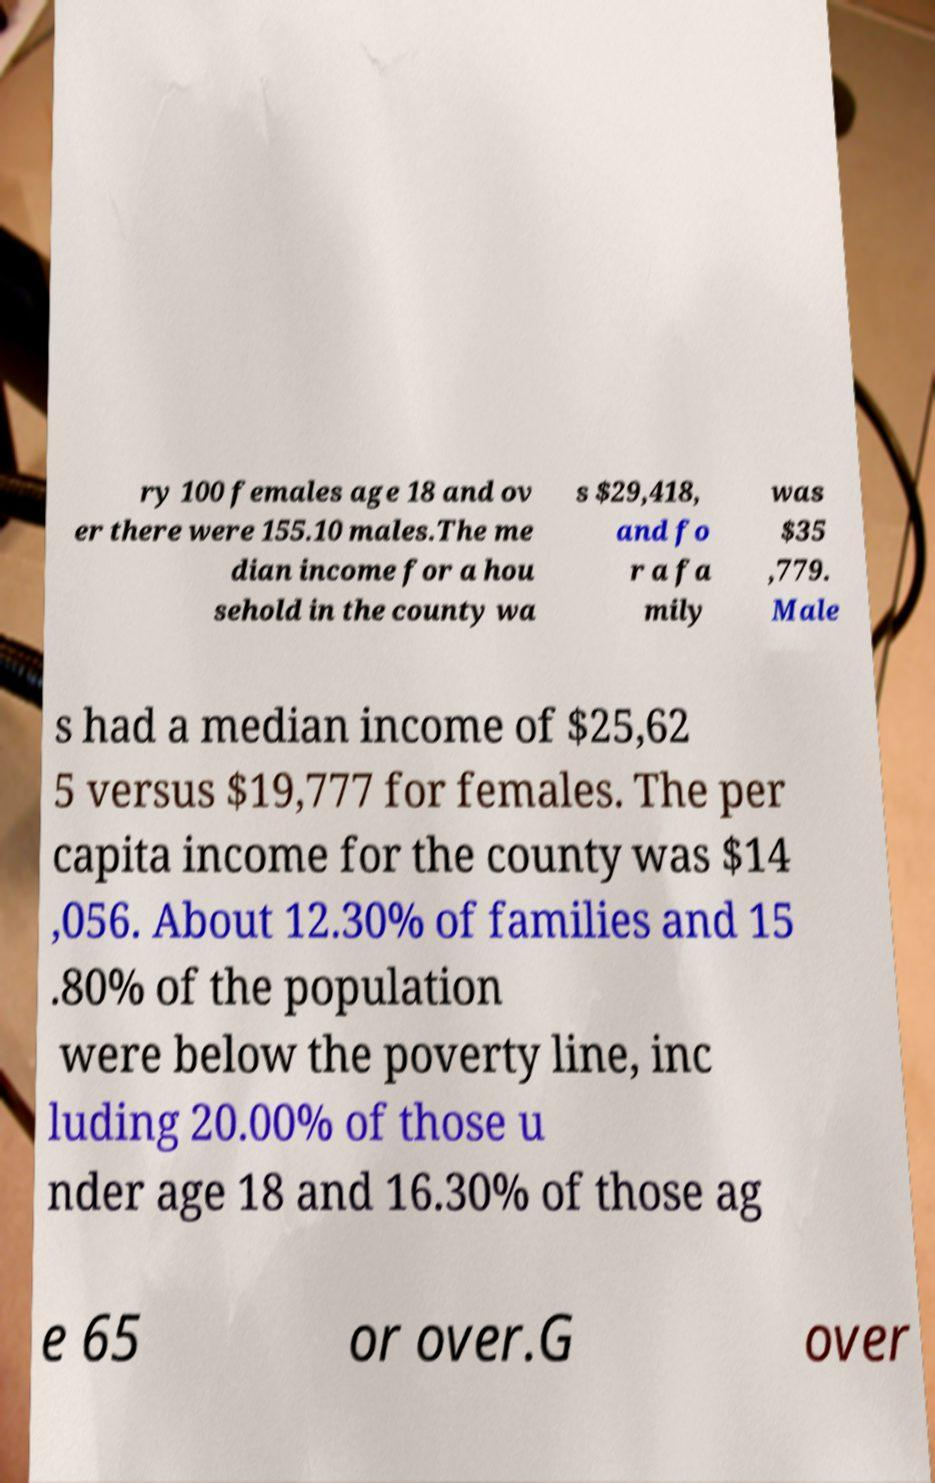Please read and relay the text visible in this image. What does it say? ry 100 females age 18 and ov er there were 155.10 males.The me dian income for a hou sehold in the county wa s $29,418, and fo r a fa mily was $35 ,779. Male s had a median income of $25,62 5 versus $19,777 for females. The per capita income for the county was $14 ,056. About 12.30% of families and 15 .80% of the population were below the poverty line, inc luding 20.00% of those u nder age 18 and 16.30% of those ag e 65 or over.G over 